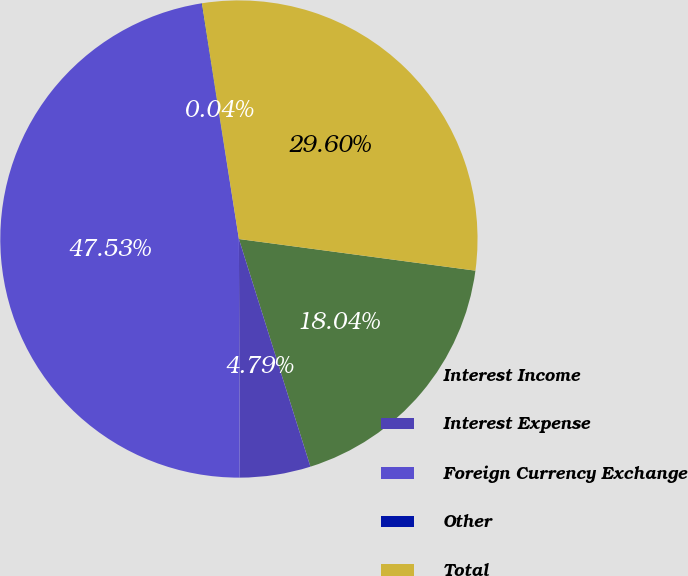Convert chart. <chart><loc_0><loc_0><loc_500><loc_500><pie_chart><fcel>Interest Income<fcel>Interest Expense<fcel>Foreign Currency Exchange<fcel>Other<fcel>Total<nl><fcel>18.04%<fcel>4.79%<fcel>47.53%<fcel>0.04%<fcel>29.6%<nl></chart> 